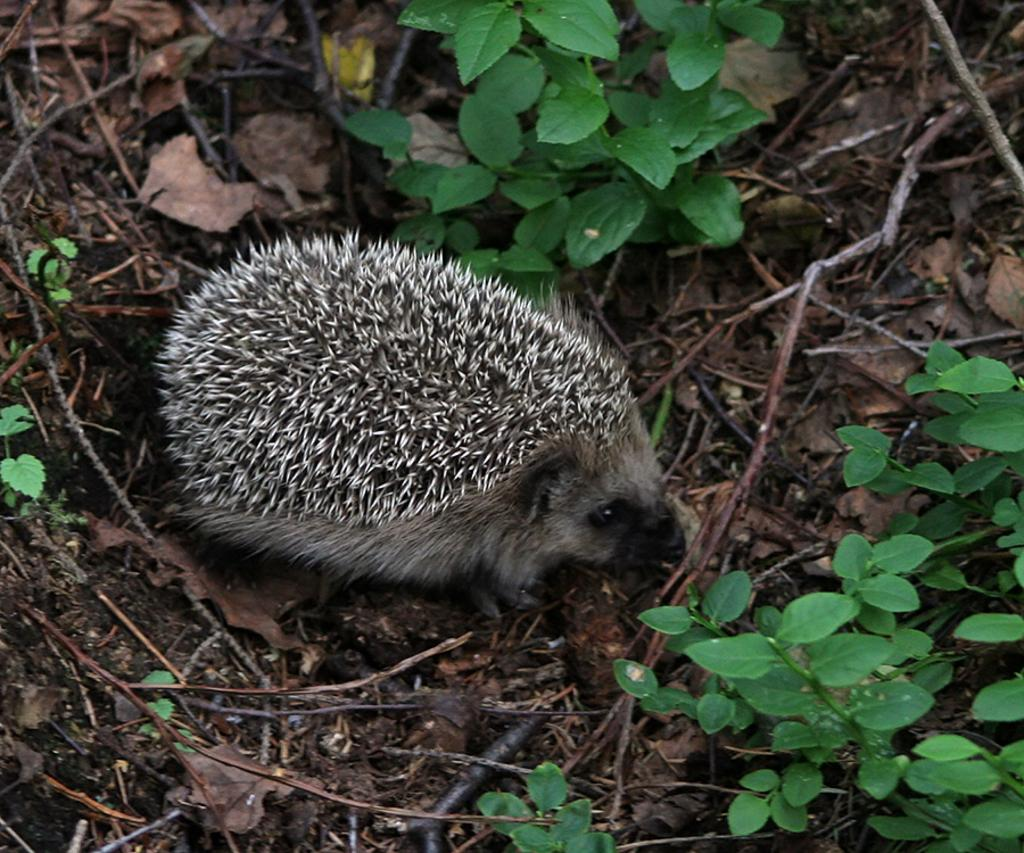What animal is on the ground in the image? There is a porcupine on the ground in the image. What type of vegetation can be seen in the image? There is a plant visible at the top of the image. What type of drug is the porcupine using in the image? There is no drug present in the image; it features a porcupine on the ground and a plant at the top. 